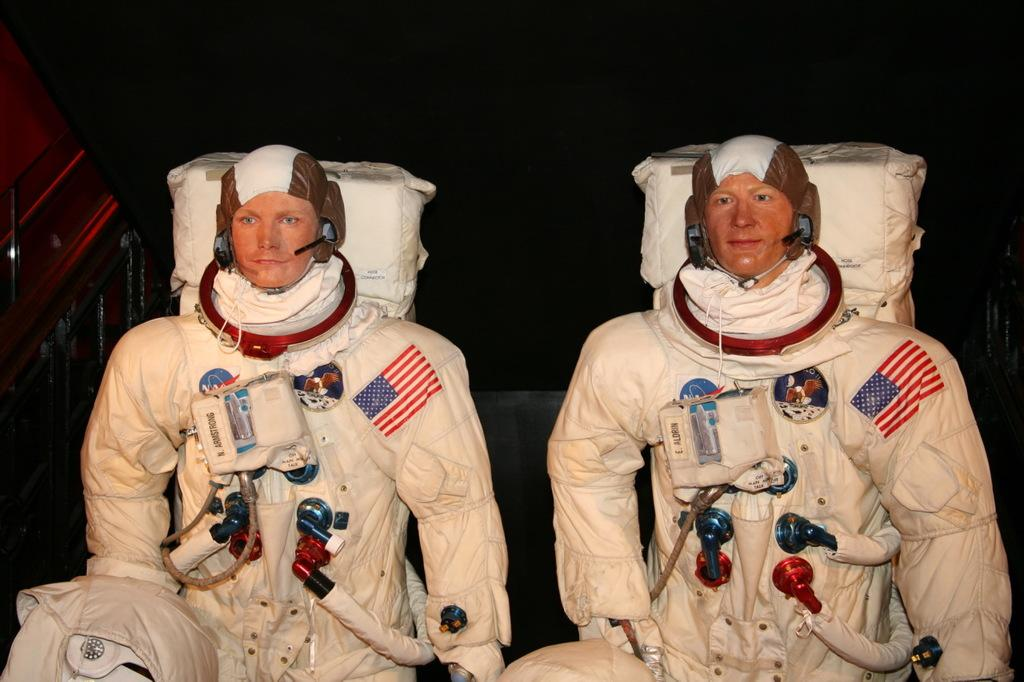How many space men are in the image? There are two space men in the image. What do the space men have with them? The space men have space equipment. What can be observed about the background of the image? The background of the image is dark. What type of birds can be seen flying in the image? There are no birds visible in the image; it features two space men with space equipment against a dark background. Is there a pig present in the image? No, there is no pig present in the image. 